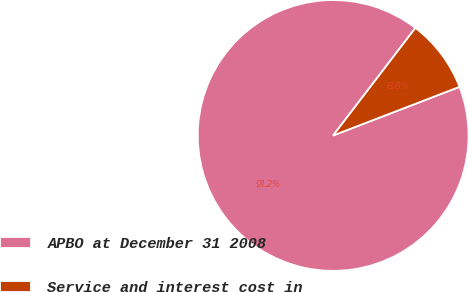<chart> <loc_0><loc_0><loc_500><loc_500><pie_chart><fcel>APBO at December 31 2008<fcel>Service and interest cost in<nl><fcel>91.24%<fcel>8.76%<nl></chart> 